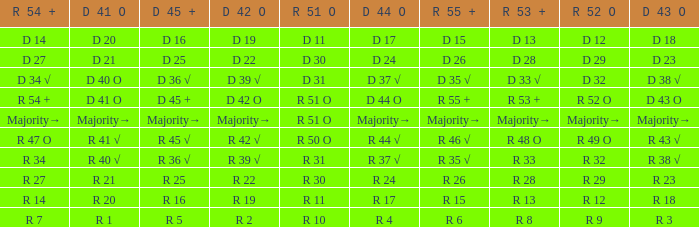What is the value of D 42 O that has an R 53 + value of r 8? R 2. 